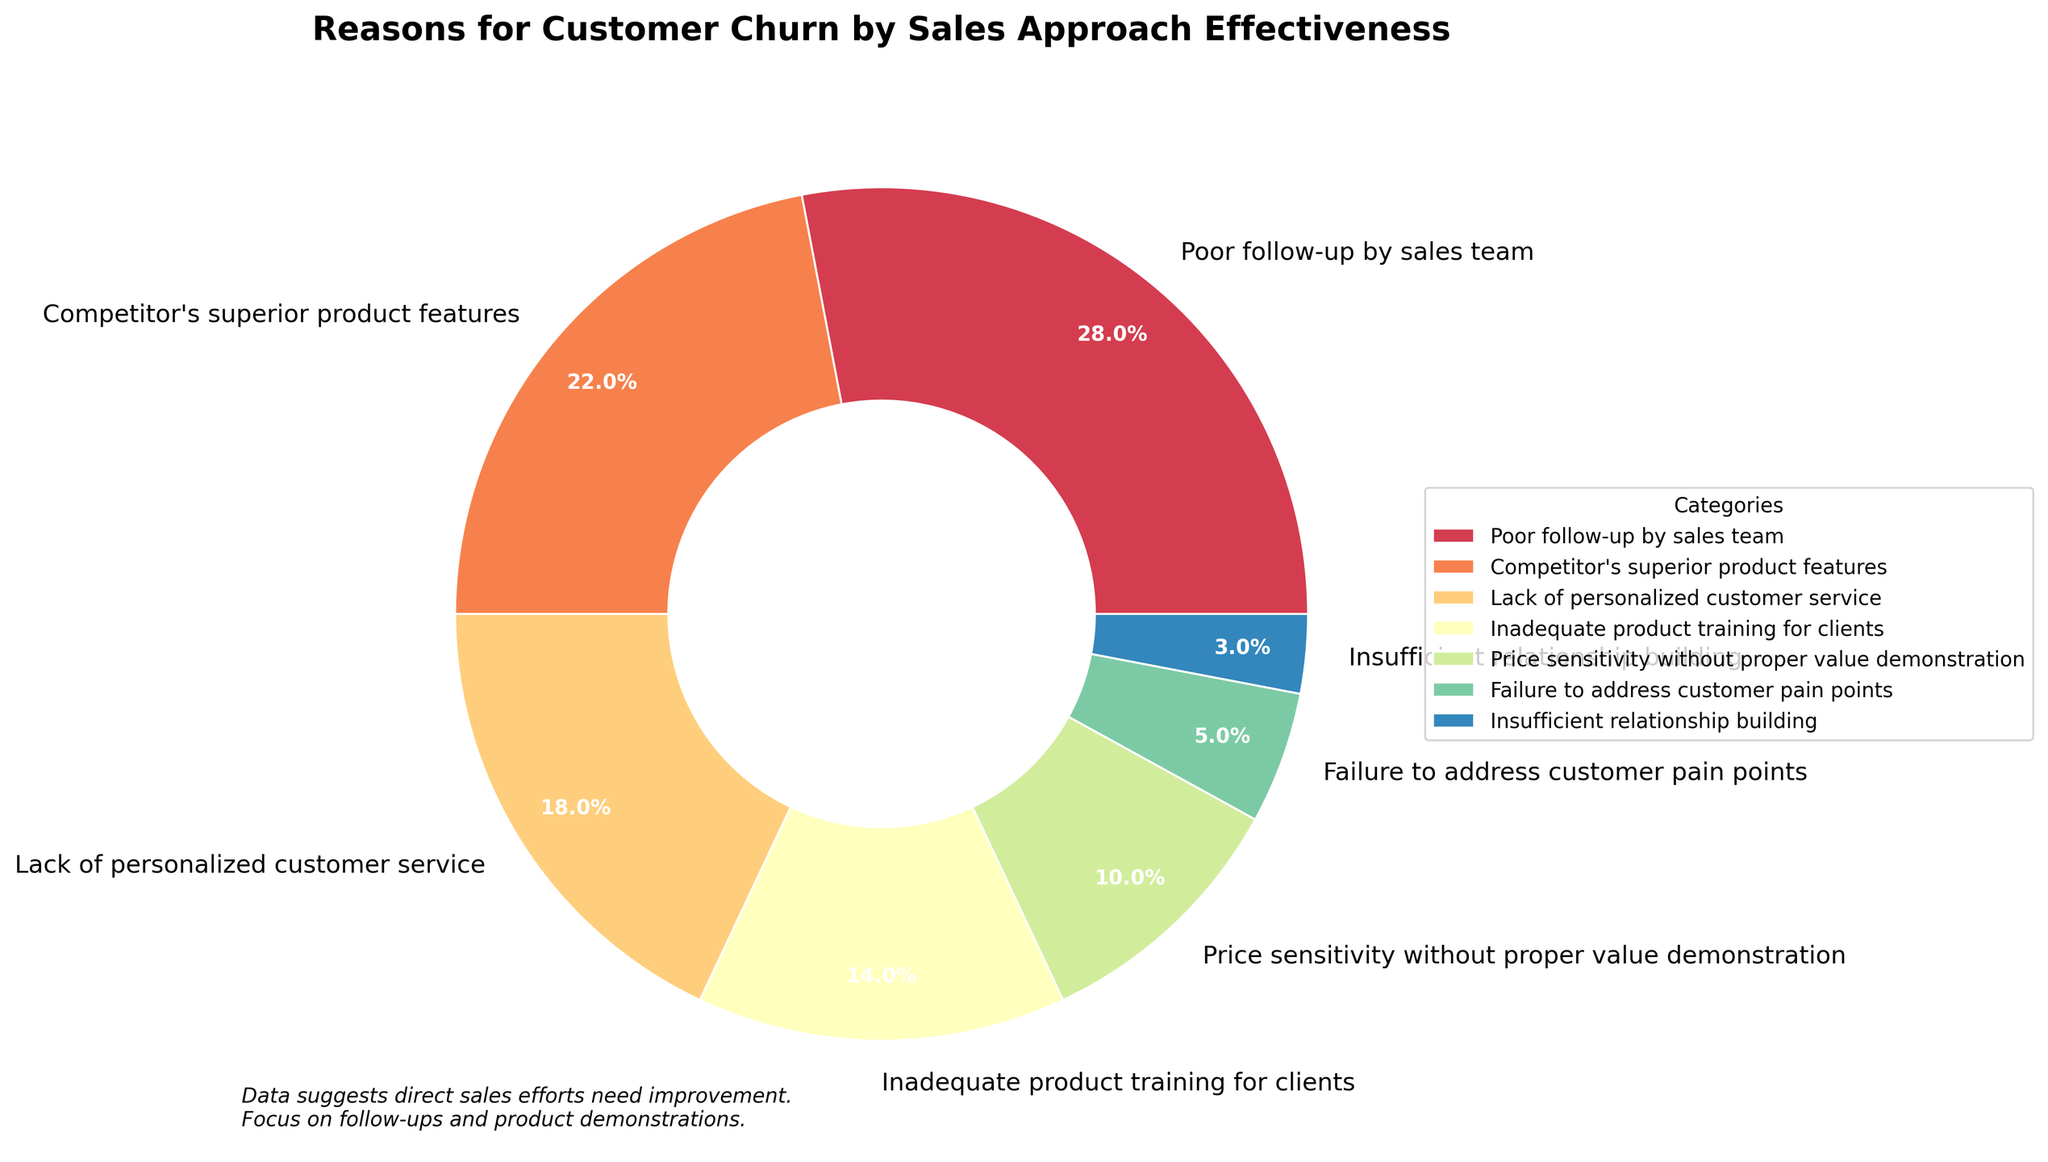What reason contributes the most to customer churn? By looking at the pie chart, the largest wedge of the pie chart represents the category with the highest percentage. The "Poor follow-up by sales team" has the largest wedge, occupying 28%.
Answer: Poor follow-up by sales team What is the combined percentage of customer churn due to "Inadequate product training for clients" and "Price sensitivity without proper value demonstration"? Add the percentages for "Inadequate product training for clients" (14%) and "Price sensitivity without proper value demonstration" (10%). So, 14% + 10% = 24%.
Answer: 24% Which reason for customer churn is more significant: "Lack of personalized customer service" or "Competitor's superior product features"? Compare the percentages of the two categories. "Competitor's superior product features" has 22% while "Lack of personalized customer service" has 18%. Thus, "Competitor's superior product features" is more significant.
Answer: Competitor's superior product features Does “Failure to address customer pain points” contribute more to customer churn than “Insufficient relationship building"? Compare the percentages of the two categories. "Failure to address customer pain points" is 5%, whereas "Insufficient relationship building" is 3%. Therefore, "Failure to address customer pain points" contributes more.
Answer: Yes What percentage of customer churn is not related to product issues (i.e., excluding "Competitor's superior product features" and "Inadequate product training for clients")? First, exclude the product-related percentages: 22% for "Competitor's superior product features" and 14% for "Inadequate product training for clients". Sum up the remaining categories: 28% + 18% + 10% + 5% + 3% = 64%.
Answer: 64% Among the reasons for customer churn, which has the least impact? Identify the category with the smallest wedge in the pie chart. "Insufficient relationship building" has the smallest percentage at 3%.
Answer: Insufficient relationship building Which two categories combined account for nearly half of the customer churn? To find two categories that sum close to 50%, look for pairs whose percentages add up close to 50%. "Poor follow-up by sales team" (28%) and "Competitor's superior product features" (22%) sum to 50%, which is nearly half.
Answer: Poor follow-up by sales team and Competitor's superior product features How much more significant is "Poor follow-up by sales team" compared to "Failure to address customer pain points"? Subtract the percentage of "Failure to address customer pain points" (5%) from "Poor follow-up by sales team" (28%). So, 28% - 5% = 23%.
Answer: 23% 